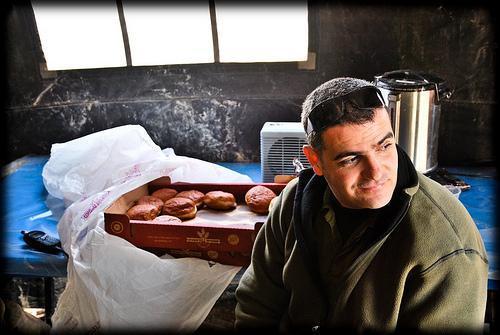How many elephants are there?
Give a very brief answer. 0. 